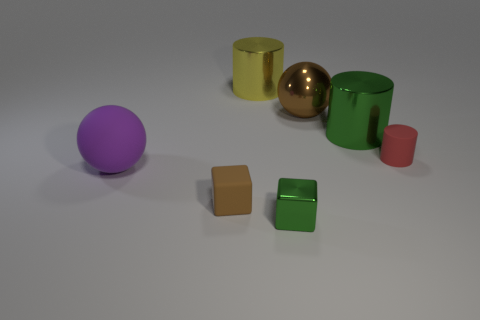Add 2 small matte things. How many objects exist? 9 Subtract all balls. How many objects are left? 5 Add 4 brown rubber things. How many brown rubber things are left? 5 Add 3 big green rubber spheres. How many big green rubber spheres exist? 3 Subtract 1 yellow cylinders. How many objects are left? 6 Subtract all tiny red rubber cylinders. Subtract all big brown things. How many objects are left? 5 